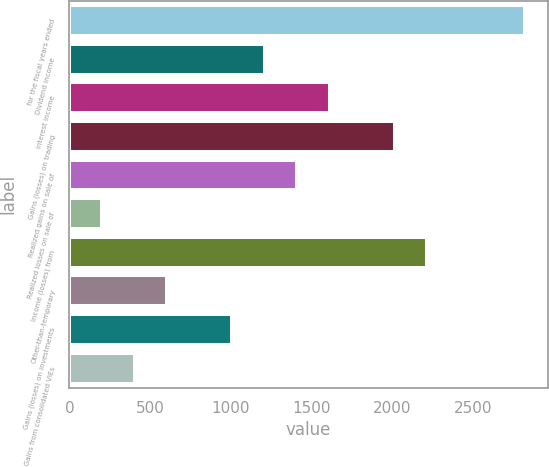Convert chart to OTSL. <chart><loc_0><loc_0><loc_500><loc_500><bar_chart><fcel>for the fiscal years ended<fcel>Dividend income<fcel>Interest income<fcel>Gains (losses) on trading<fcel>Realized gains on sale of<fcel>Realized losses on sale of<fcel>Income (losses) from<fcel>Other-than-temporary<fcel>Gains (losses) on investments<fcel>Gains from consolidated VIEs<nl><fcel>2821.24<fcel>1210.76<fcel>1613.38<fcel>2016<fcel>1412.07<fcel>204.21<fcel>2217.31<fcel>606.83<fcel>1009.45<fcel>405.52<nl></chart> 